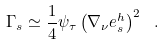Convert formula to latex. <formula><loc_0><loc_0><loc_500><loc_500>\Gamma _ { s } \simeq \frac { 1 } { 4 } \psi _ { \tau } \left ( \nabla _ { \nu } e ^ { h } _ { s } \right ) ^ { 2 } \ .</formula> 